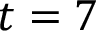Convert formula to latex. <formula><loc_0><loc_0><loc_500><loc_500>t = 7</formula> 